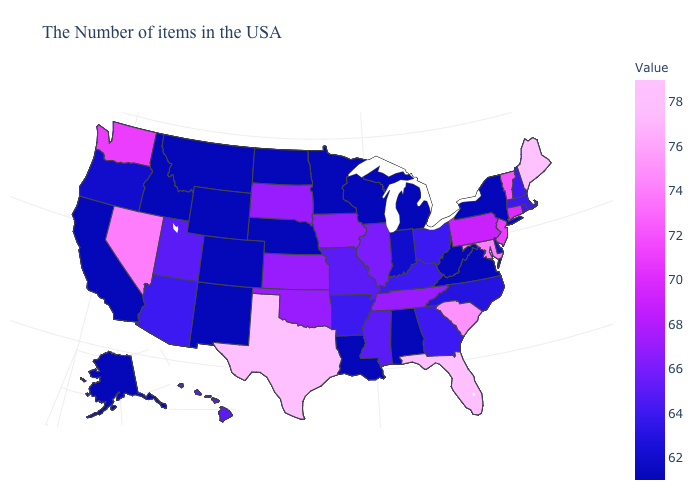Among the states that border New York , which have the highest value?
Give a very brief answer. Vermont. Does Maine have the highest value in the USA?
Quick response, please. Yes. Among the states that border Tennessee , which have the highest value?
Concise answer only. Mississippi, Missouri. Does Kentucky have the highest value in the USA?
Write a very short answer. No. Which states hav the highest value in the MidWest?
Keep it brief. Iowa, Kansas, South Dakota. 